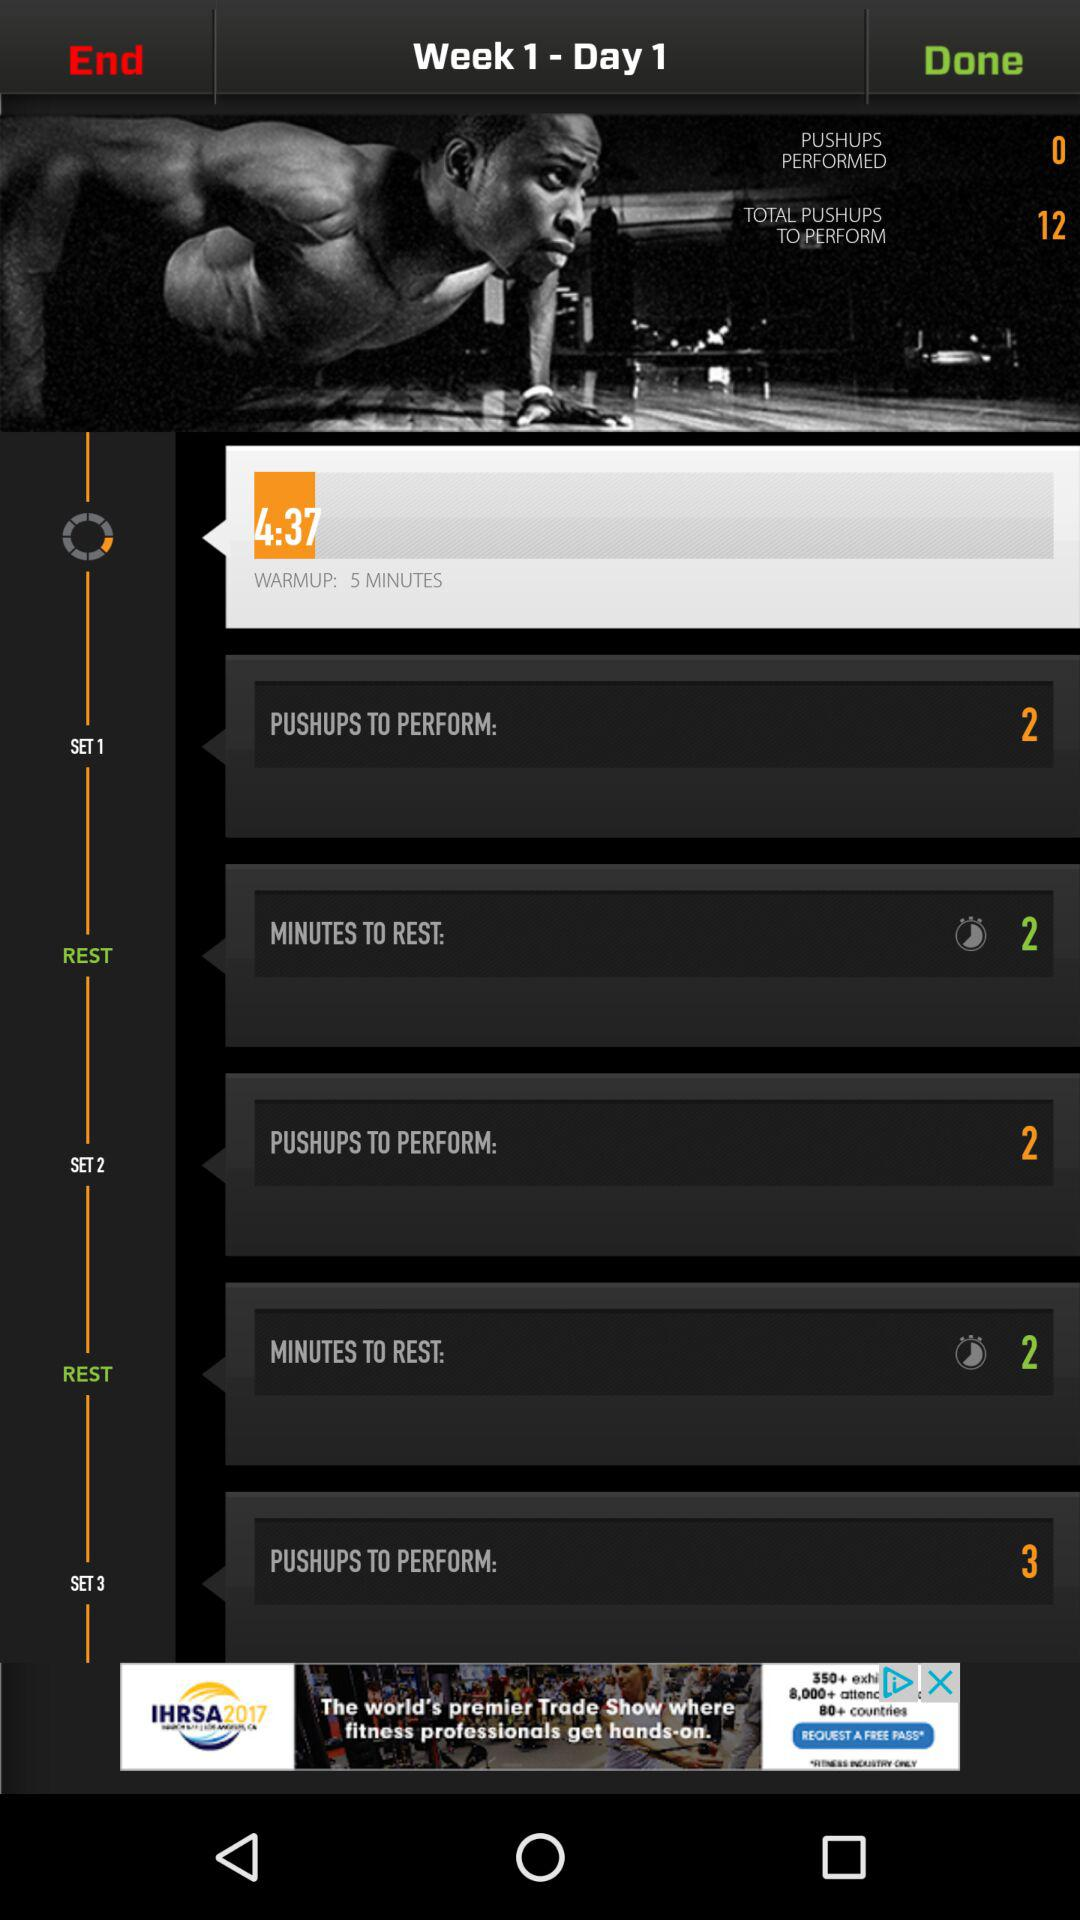How many more pushups do I need to perform?
Answer the question using a single word or phrase. 12 